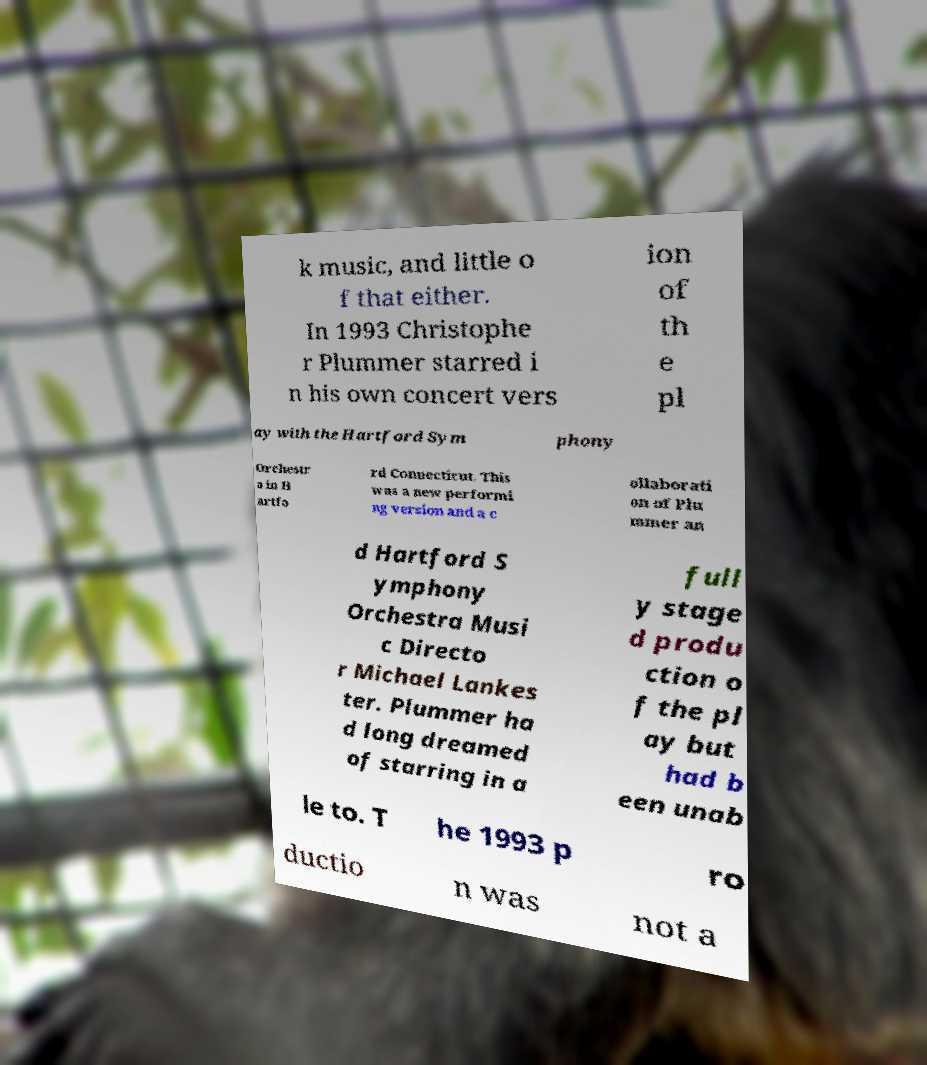There's text embedded in this image that I need extracted. Can you transcribe it verbatim? k music, and little o f that either. In 1993 Christophe r Plummer starred i n his own concert vers ion of th e pl ay with the Hartford Sym phony Orchestr a in H artfo rd Connecticut. This was a new performi ng version and a c ollaborati on of Plu mmer an d Hartford S ymphony Orchestra Musi c Directo r Michael Lankes ter. Plummer ha d long dreamed of starring in a full y stage d produ ction o f the pl ay but had b een unab le to. T he 1993 p ro ductio n was not a 